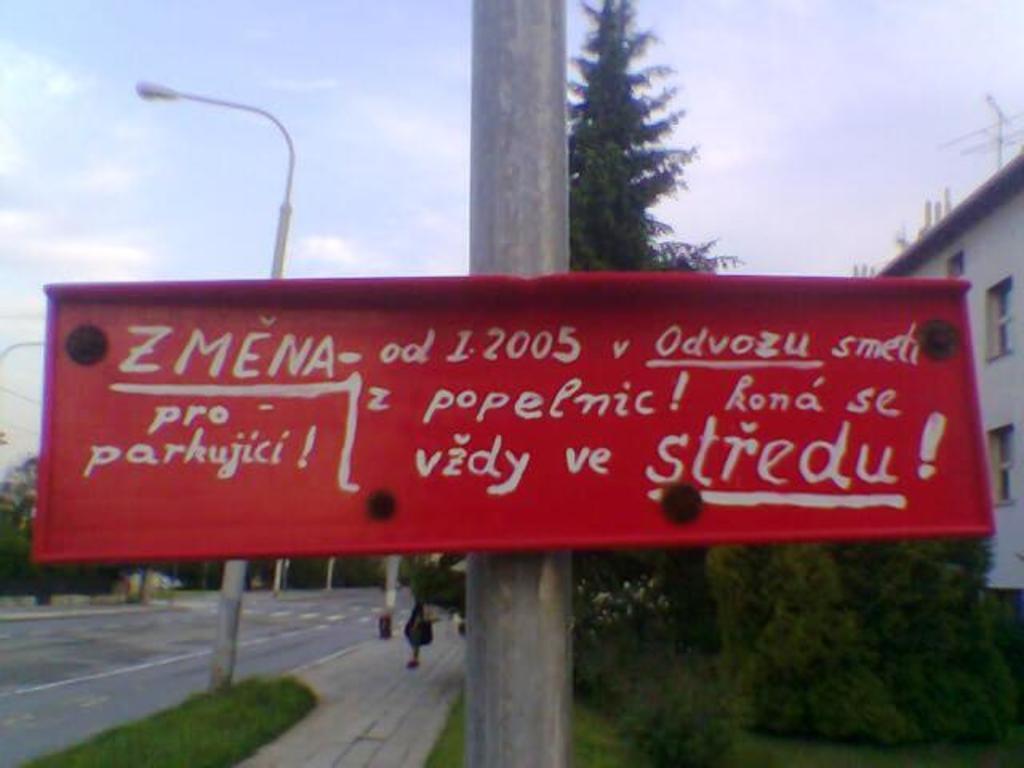Could you give a brief overview of what you see in this image? In this image there is a pole in the middle. To the pole there is a board. On the right side there is a building. On the building there are antennas. In front of the building there are trees. On the left side there is a road. There are light poles on the footpath. At the top there is the sky. There is a person on the footpath. 